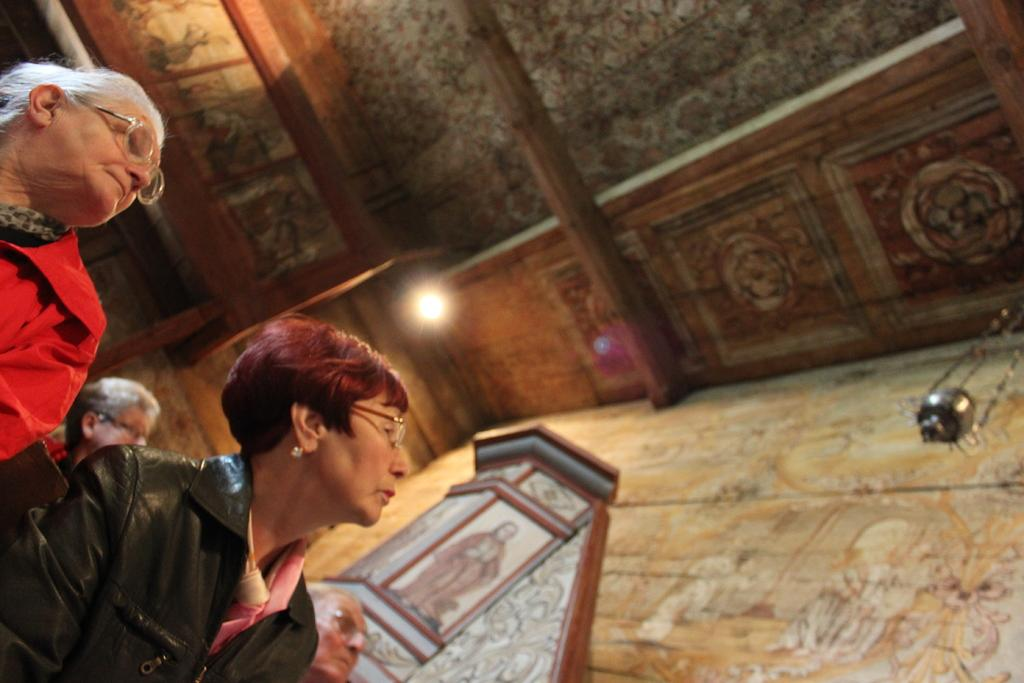How many people are in the image? There is a group of people standing in the image, but the exact number cannot be determined from the provided facts. What is located behind the group of people? There is a wall in the image. What is the source of light in the image? There is a light in the image. What is above the group of people and the wall? There is a roof in the image. How many birds are sitting on the sign in the image? There is no sign or birds present in the image. What type of crib is visible in the image? There is no crib present in the image. 